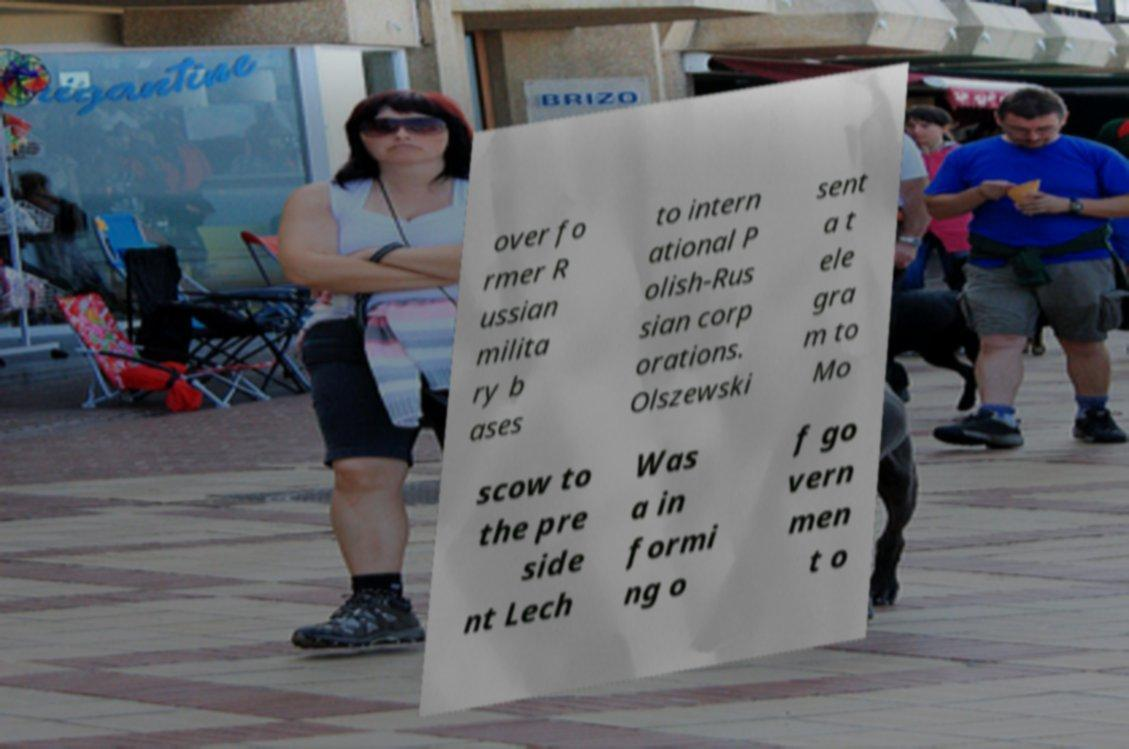Can you accurately transcribe the text from the provided image for me? over fo rmer R ussian milita ry b ases to intern ational P olish-Rus sian corp orations. Olszewski sent a t ele gra m to Mo scow to the pre side nt Lech Was a in formi ng o f go vern men t o 